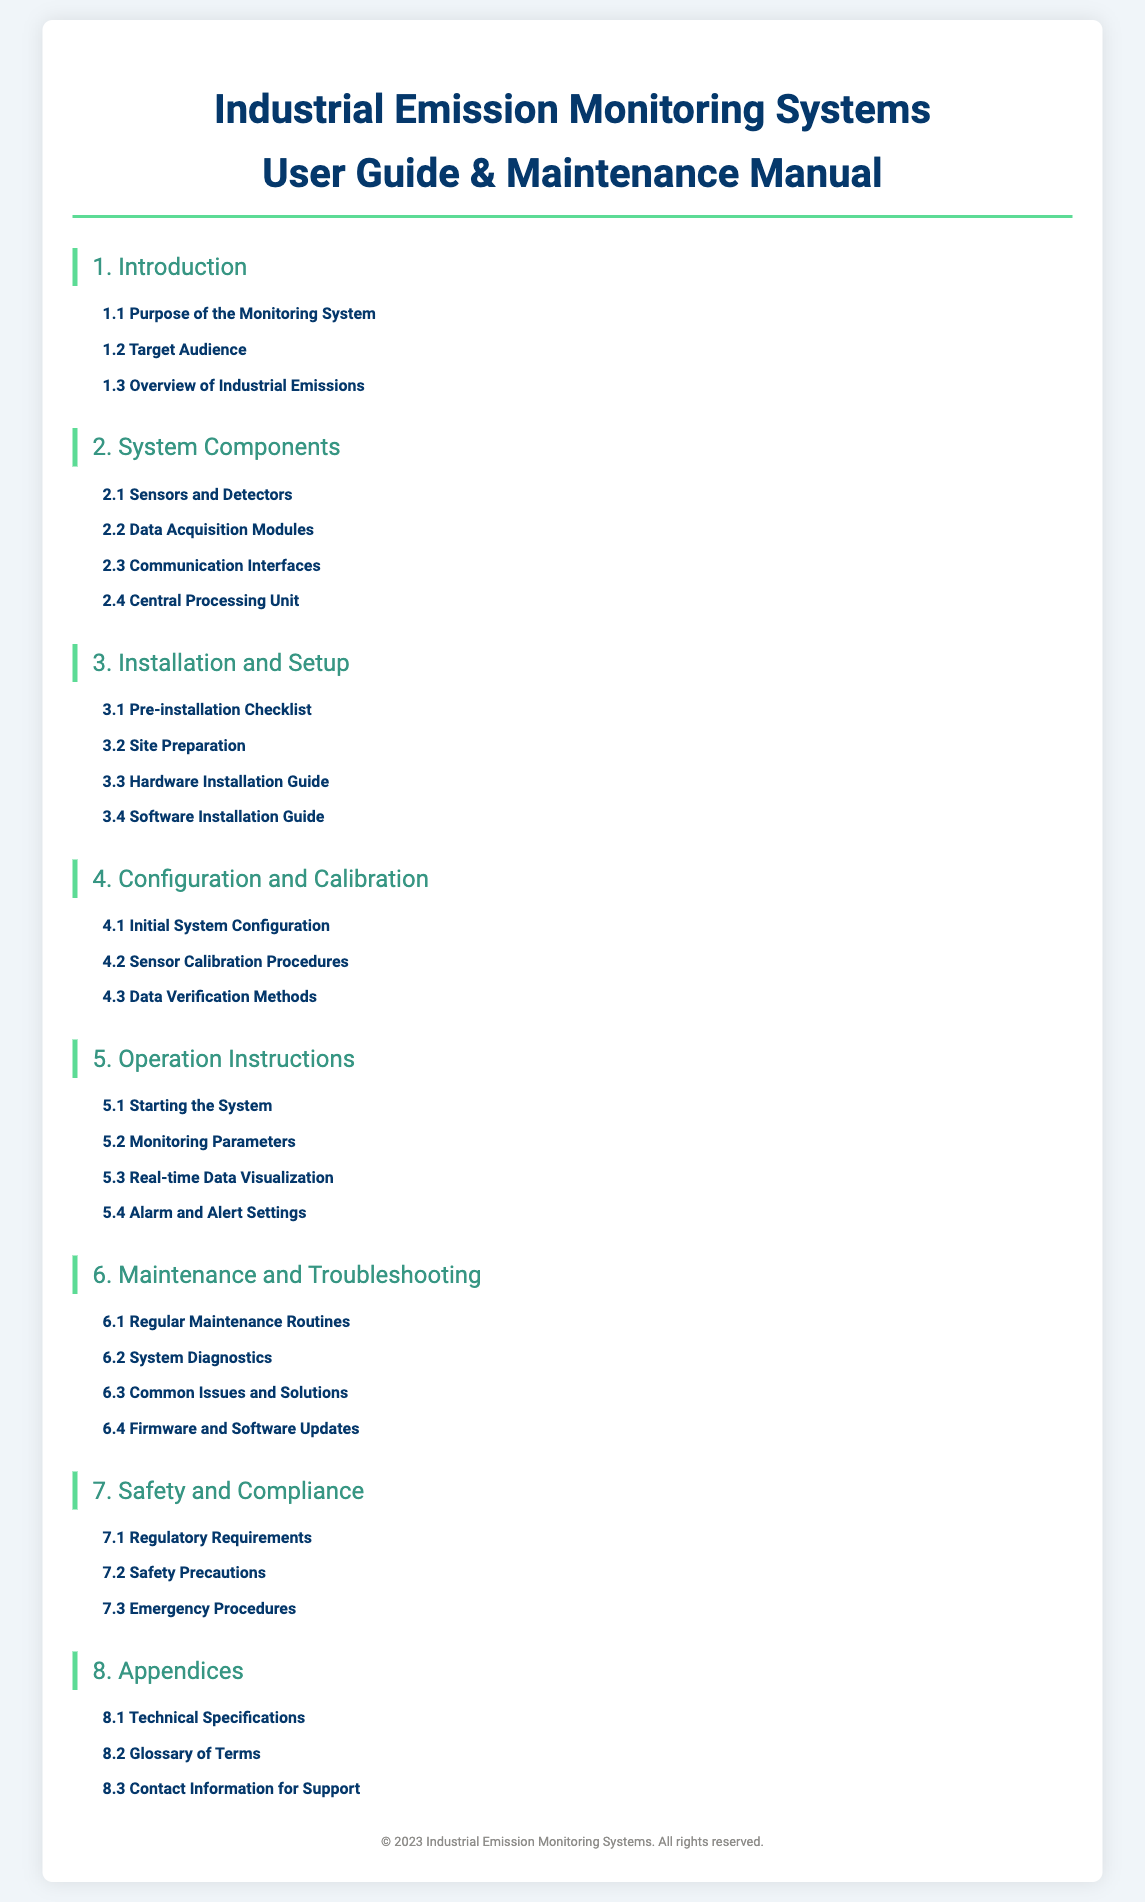what is the primary objective of the monitoring system? The purpose of the monitoring system is to focus on pollution reduction, regulatory compliance, and sustainability goals.
Answer: pollution reduction, regulatory compliance, and sustainability goals who is the target audience for the user guide? The user guide is primarily intended for engineers, maintenance staff, and environmental compliance officers.
Answer: engineers, maintenance staff, and environmental compliance officers what types of sensors are mentioned in the system components? The section details electrochemical sensors and infrared detectors used in monitoring emissions.
Answer: electrochemical sensors, infrared detectors how many items are listed in the pre-installation checklist? The pre-installation checklist is a list of items and conditions to verify before installation, though the exact number isn't specified.
Answer: not specified what are the key metrics to track during operation? The document mentions concentration levels and flow rates as key metrics to monitor.
Answer: concentration levels and flow rates what is the first section of the user guide? The first section of the user guide is titled "Introduction."
Answer: Introduction which section would you refer to for troubleshooting performance issues? The section dedicated to troubleshooting performance issues is titled "System Diagnostics."
Answer: System Diagnostics how often should maintenance routines be performed? The document states regular maintenance routines should be scheduled to keep the system running efficiently, though specific frequency isn't detailed.
Answer: not specified what is the purpose of the technical specifications appendix? The technical specifications appendix provides detailed technical data for all system components.
Answer: detailed technical data for all system components what does the emergency procedures section cover? The emergency procedures section outlines steps to take in case of a system malfunction or other emergencies.
Answer: steps to take in case of a system malfunction or other emergencies 